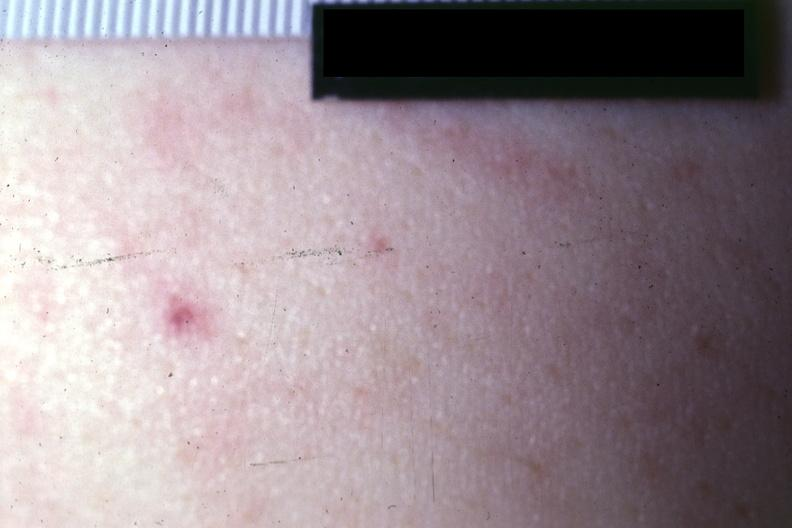s petechiae present?
Answer the question using a single word or phrase. Yes 